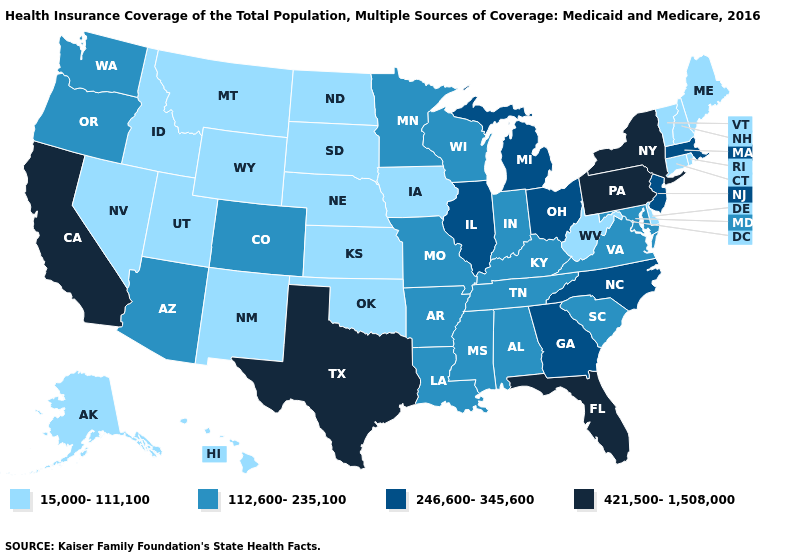Name the states that have a value in the range 421,500-1,508,000?
Keep it brief. California, Florida, New York, Pennsylvania, Texas. Name the states that have a value in the range 421,500-1,508,000?
Answer briefly. California, Florida, New York, Pennsylvania, Texas. Name the states that have a value in the range 421,500-1,508,000?
Be succinct. California, Florida, New York, Pennsylvania, Texas. What is the lowest value in states that border Arkansas?
Be succinct. 15,000-111,100. Name the states that have a value in the range 112,600-235,100?
Quick response, please. Alabama, Arizona, Arkansas, Colorado, Indiana, Kentucky, Louisiana, Maryland, Minnesota, Mississippi, Missouri, Oregon, South Carolina, Tennessee, Virginia, Washington, Wisconsin. How many symbols are there in the legend?
Answer briefly. 4. Name the states that have a value in the range 15,000-111,100?
Short answer required. Alaska, Connecticut, Delaware, Hawaii, Idaho, Iowa, Kansas, Maine, Montana, Nebraska, Nevada, New Hampshire, New Mexico, North Dakota, Oklahoma, Rhode Island, South Dakota, Utah, Vermont, West Virginia, Wyoming. Name the states that have a value in the range 246,600-345,600?
Quick response, please. Georgia, Illinois, Massachusetts, Michigan, New Jersey, North Carolina, Ohio. What is the value of South Carolina?
Give a very brief answer. 112,600-235,100. Which states hav the highest value in the MidWest?
Be succinct. Illinois, Michigan, Ohio. Name the states that have a value in the range 15,000-111,100?
Concise answer only. Alaska, Connecticut, Delaware, Hawaii, Idaho, Iowa, Kansas, Maine, Montana, Nebraska, Nevada, New Hampshire, New Mexico, North Dakota, Oklahoma, Rhode Island, South Dakota, Utah, Vermont, West Virginia, Wyoming. Does Vermont have a lower value than Nebraska?
Be succinct. No. What is the value of California?
Be succinct. 421,500-1,508,000. How many symbols are there in the legend?
Quick response, please. 4. Name the states that have a value in the range 112,600-235,100?
Be succinct. Alabama, Arizona, Arkansas, Colorado, Indiana, Kentucky, Louisiana, Maryland, Minnesota, Mississippi, Missouri, Oregon, South Carolina, Tennessee, Virginia, Washington, Wisconsin. 